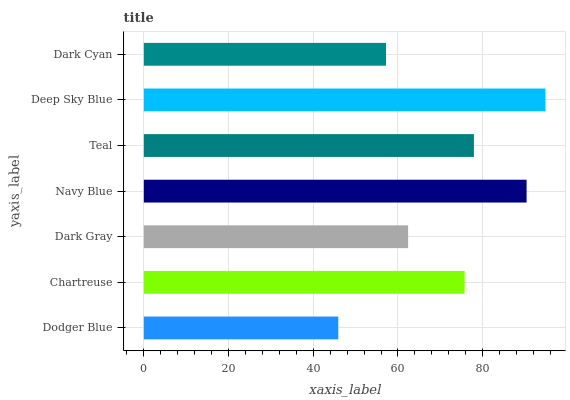Is Dodger Blue the minimum?
Answer yes or no. Yes. Is Deep Sky Blue the maximum?
Answer yes or no. Yes. Is Chartreuse the minimum?
Answer yes or no. No. Is Chartreuse the maximum?
Answer yes or no. No. Is Chartreuse greater than Dodger Blue?
Answer yes or no. Yes. Is Dodger Blue less than Chartreuse?
Answer yes or no. Yes. Is Dodger Blue greater than Chartreuse?
Answer yes or no. No. Is Chartreuse less than Dodger Blue?
Answer yes or no. No. Is Chartreuse the high median?
Answer yes or no. Yes. Is Chartreuse the low median?
Answer yes or no. Yes. Is Dark Gray the high median?
Answer yes or no. No. Is Dark Gray the low median?
Answer yes or no. No. 